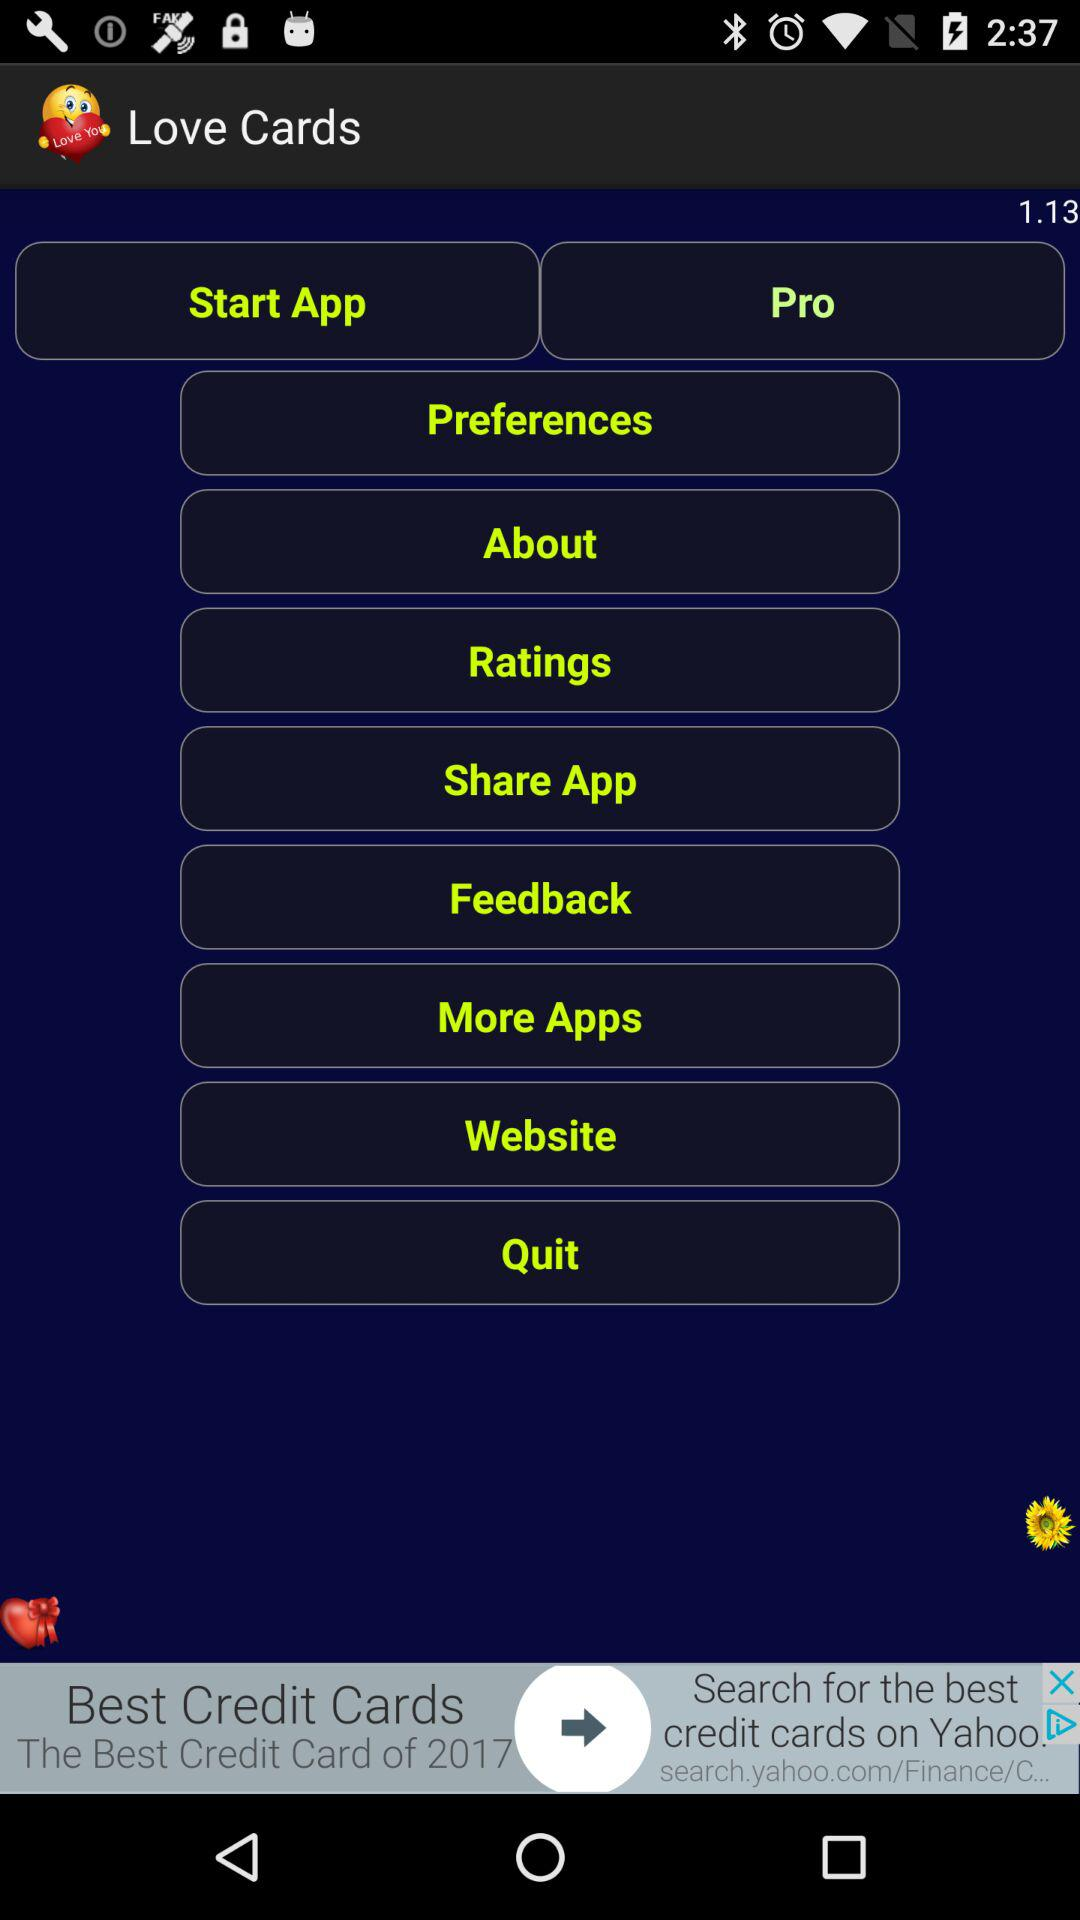What is the application name? The application name is "Love Cards". 